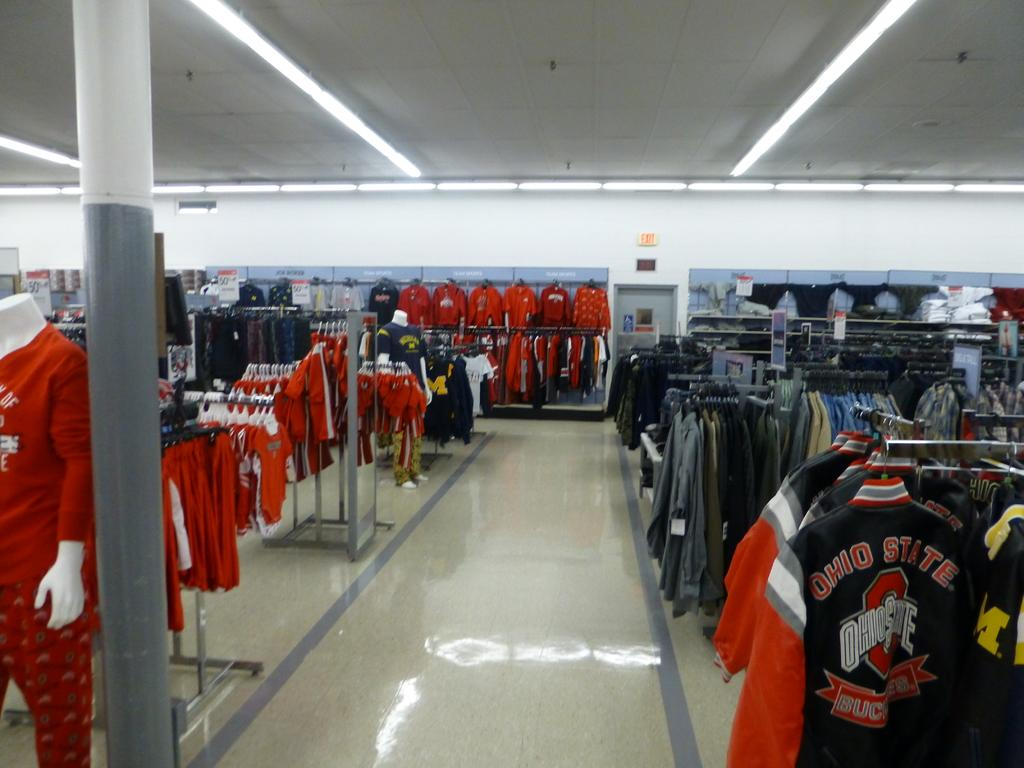<image>
Create a compact narrative representing the image presented. many clothing items that have Ohio State written on them 